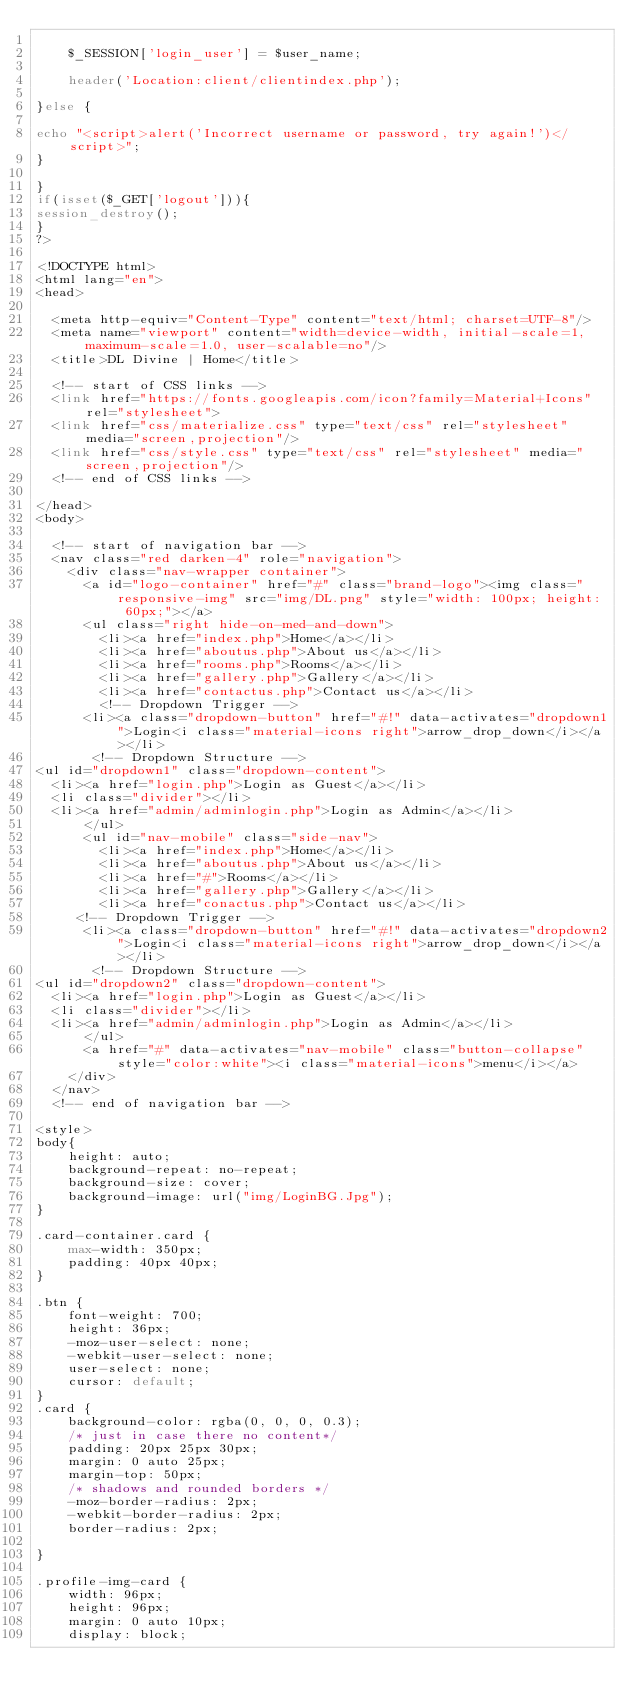Convert code to text. <code><loc_0><loc_0><loc_500><loc_500><_PHP_>
	$_SESSION['login_user'] = $user_name;

	header('Location:client/clientindex.php');	

}else {
	
echo "<script>alert('Incorrect username or password, try again!')</script>";
}

}
if(isset($_GET['logout'])){
session_destroy();
}
?>

<!DOCTYPE html>
<html lang="en">
<head>

  <meta http-equiv="Content-Type" content="text/html; charset=UTF-8"/>
  <meta name="viewport" content="width=device-width, initial-scale=1, maximum-scale=1.0, user-scalable=no"/>
  <title>DL Divine | Home</title>

  <!-- start of CSS links -->
  <link href="https://fonts.googleapis.com/icon?family=Material+Icons" rel="stylesheet">
  <link href="css/materialize.css" type="text/css" rel="stylesheet" media="screen,projection"/>
  <link href="css/style.css" type="text/css" rel="stylesheet" media="screen,projection"/>
  <!-- end of CSS links -->

</head>
<body>

  <!-- start of navigation bar -->
  <nav class="red darken-4" role="navigation">
    <div class="nav-wrapper container">
      <a id="logo-container" href="#" class="brand-logo"><img class="responsive-img" src="img/DL.png" style="width: 100px; height: 60px;"></a>
      <ul class="right hide-on-med-and-down">
        <li><a href="index.php">Home</a></li>
        <li><a href="aboutus.php">About us</a></li>
        <li><a href="rooms.php">Rooms</a></li>
        <li><a href="gallery.php">Gallery</a></li>
        <li><a href="contactus.php">Contact us</a></li>
        <!-- Dropdown Trigger -->
      <li><a class="dropdown-button" href="#!" data-activates="dropdown1">Login<i class="material-icons right">arrow_drop_down</i></a></li>
       <!-- Dropdown Structure -->
<ul id="dropdown1" class="dropdown-content">
  <li><a href="login.php">Login as Guest</a></li>
  <li class="divider"></li>
  <li><a href="admin/adminlogin.php">Login as Admin</a></li>
      </ul>
      <ul id="nav-mobile" class="side-nav">
        <li><a href="index.php">Home</a></li>
        <li><a href="aboutus.php">About us</a></li>
        <li><a href="#">Rooms</a></li>
        <li><a href="gallery.php">Gallery</a></li>
        <li><a href="conactus.php">Contact us</a></li>
     <!-- Dropdown Trigger -->
      <li><a class="dropdown-button" href="#!" data-activates="dropdown2">Login<i class="material-icons right">arrow_drop_down</i></a></li>
       <!-- Dropdown Structure -->
<ul id="dropdown2" class="dropdown-content">
  <li><a href="login.php">Login as Guest</a></li>
  <li class="divider"></li>
  <li><a href="admin/adminlogin.php">Login as Admin</a></li>
      </ul>
      <a href="#" data-activates="nav-mobile" class="button-collapse" style="color:white"><i class="material-icons">menu</i></a>
    </div>
  </nav>
  <!-- end of navigation bar -->

<style>
body{
    height: auto;
    background-repeat: no-repeat;
    background-size: cover;
    background-image: url("img/LoginBG.Jpg");
}

.card-container.card {
    max-width: 350px;
    padding: 40px 40px;
}

.btn {
    font-weight: 700;
    height: 36px;
    -moz-user-select: none;
    -webkit-user-select: none;
    user-select: none;
    cursor: default;
}
.card {
    background-color: rgba(0, 0, 0, 0.3);
    /* just in case there no content*/
    padding: 20px 25px 30px;
    margin: 0 auto 25px;
    margin-top: 50px;
    /* shadows and rounded borders */
    -moz-border-radius: 2px;
    -webkit-border-radius: 2px;
    border-radius: 2px;

}

.profile-img-card {
    width: 96px;
    height: 96px;
    margin: 0 auto 10px;
    display: block;</code> 